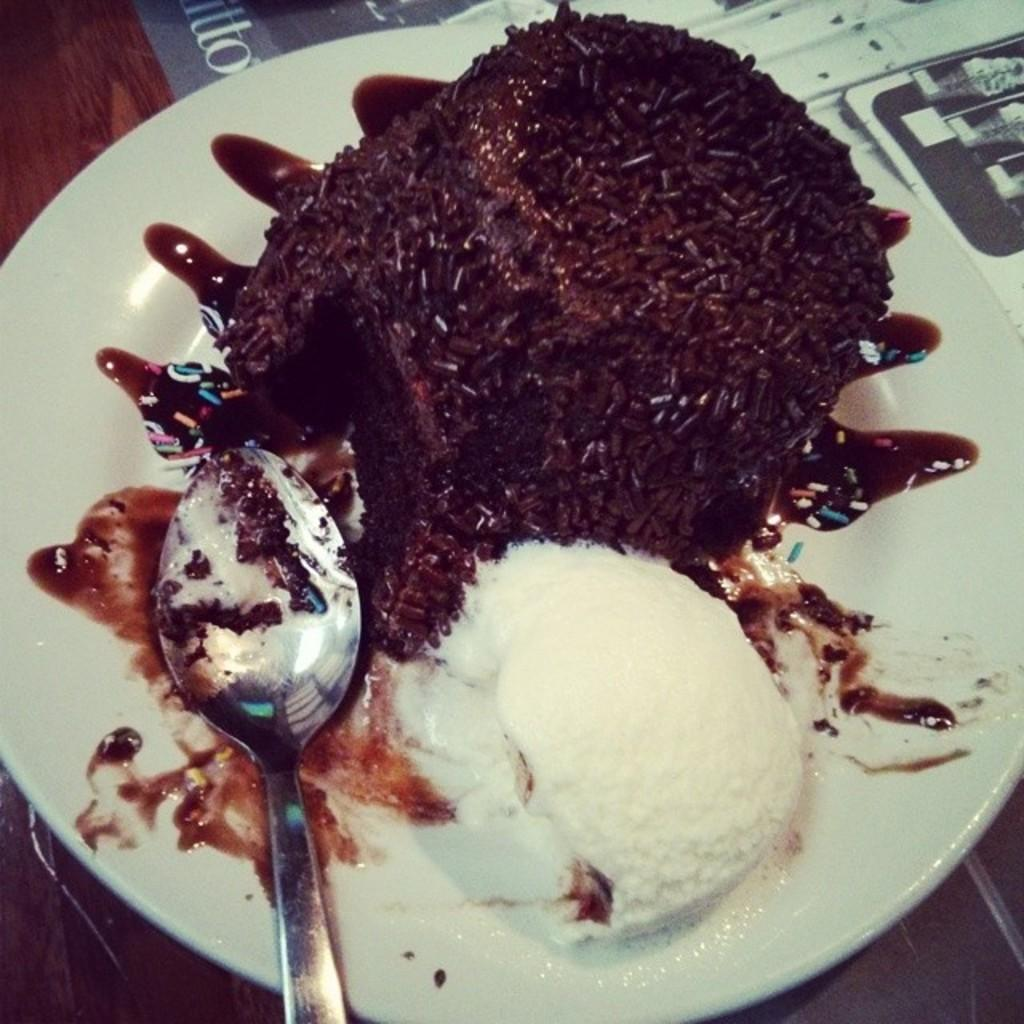What is on the plate in the image? There is a cake on the plate, and a spoon is present on the plate. Where might the plate be located? The plate may be on a table. What type of establishment might the image have been taken in? The image may have been taken in a restaurant. What type of paper is the cake made of in the image? The cake is not made of paper; it is a real cake made of edible ingredients. 